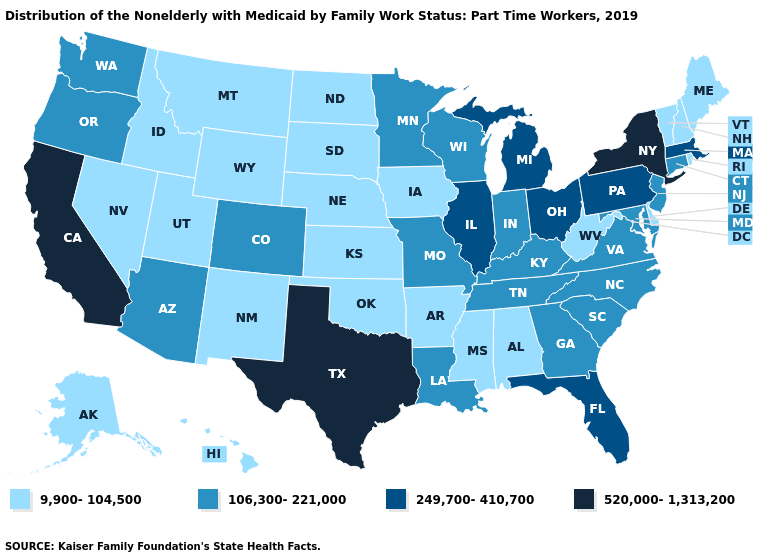Which states have the lowest value in the USA?
Keep it brief. Alabama, Alaska, Arkansas, Delaware, Hawaii, Idaho, Iowa, Kansas, Maine, Mississippi, Montana, Nebraska, Nevada, New Hampshire, New Mexico, North Dakota, Oklahoma, Rhode Island, South Dakota, Utah, Vermont, West Virginia, Wyoming. Does Georgia have a lower value than Texas?
Concise answer only. Yes. Name the states that have a value in the range 520,000-1,313,200?
Be succinct. California, New York, Texas. Does Indiana have a lower value than Delaware?
Be succinct. No. What is the value of South Dakota?
Write a very short answer. 9,900-104,500. Which states have the lowest value in the MidWest?
Be succinct. Iowa, Kansas, Nebraska, North Dakota, South Dakota. What is the highest value in the USA?
Quick response, please. 520,000-1,313,200. Does Nebraska have the lowest value in the USA?
Give a very brief answer. Yes. What is the lowest value in states that border New Hampshire?
Answer briefly. 9,900-104,500. Which states hav the highest value in the Northeast?
Quick response, please. New York. Is the legend a continuous bar?
Answer briefly. No. Is the legend a continuous bar?
Answer briefly. No. Does the first symbol in the legend represent the smallest category?
Give a very brief answer. Yes. What is the value of Alabama?
Answer briefly. 9,900-104,500. Name the states that have a value in the range 520,000-1,313,200?
Give a very brief answer. California, New York, Texas. 